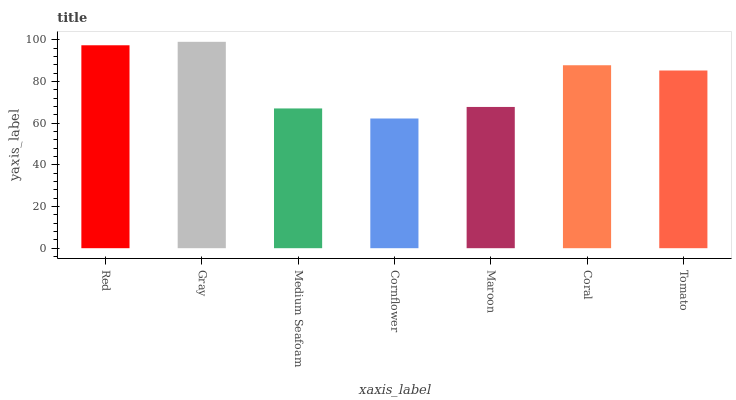Is Cornflower the minimum?
Answer yes or no. Yes. Is Gray the maximum?
Answer yes or no. Yes. Is Medium Seafoam the minimum?
Answer yes or no. No. Is Medium Seafoam the maximum?
Answer yes or no. No. Is Gray greater than Medium Seafoam?
Answer yes or no. Yes. Is Medium Seafoam less than Gray?
Answer yes or no. Yes. Is Medium Seafoam greater than Gray?
Answer yes or no. No. Is Gray less than Medium Seafoam?
Answer yes or no. No. Is Tomato the high median?
Answer yes or no. Yes. Is Tomato the low median?
Answer yes or no. Yes. Is Maroon the high median?
Answer yes or no. No. Is Red the low median?
Answer yes or no. No. 